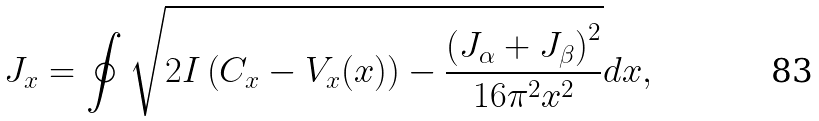<formula> <loc_0><loc_0><loc_500><loc_500>J _ { x } = \oint \sqrt { 2 I \left ( C _ { x } - V _ { x } ( x ) \right ) - \frac { \left ( J _ { \alpha } + J _ { \beta } \right ) ^ { 2 } } { 1 6 \pi ^ { 2 } x ^ { 2 } } } d x ,</formula> 